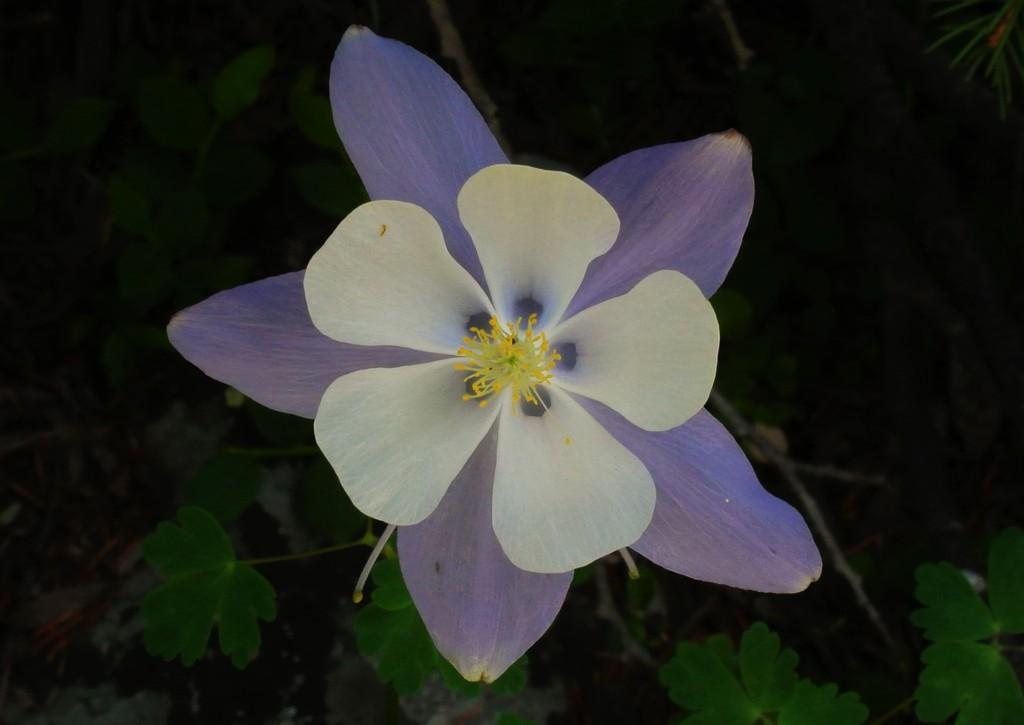Could you give a brief overview of what you see in this image? In this image we can see a flower in lavender and white color. There are leaves and stems in the background. 